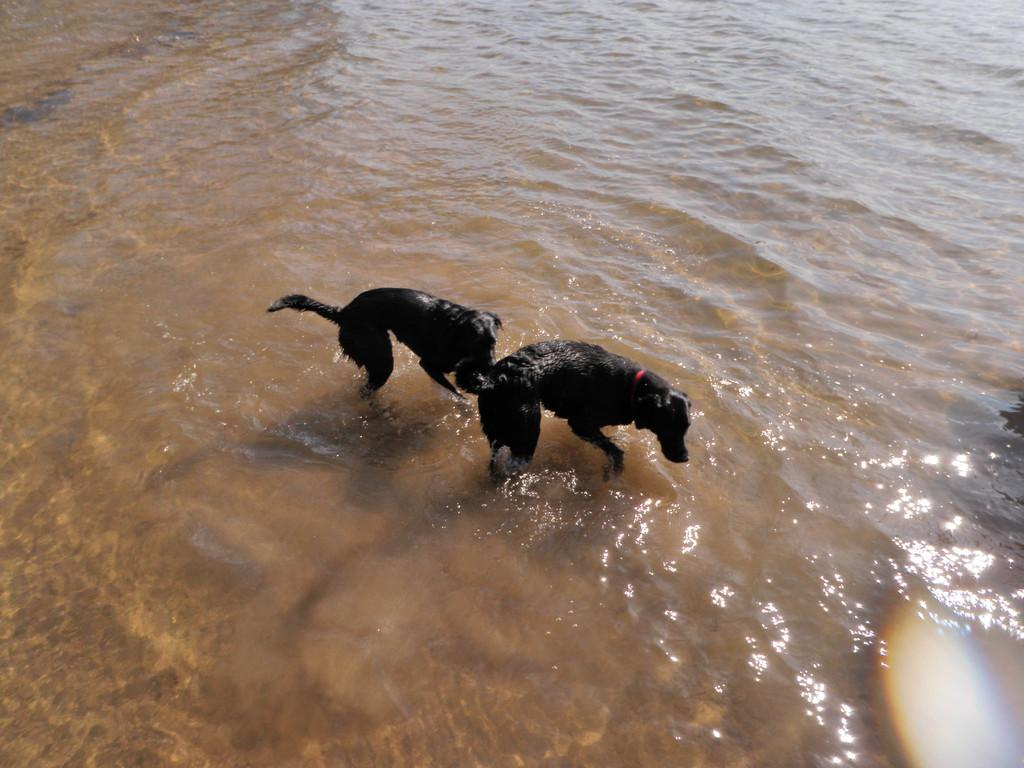How many dogs are present in the image? There are two dogs in the image. What are the dogs doing in the image? The dogs are standing in water. What type of cushion can be seen supporting the dogs in the image? There is no cushion present in the image; the dogs are standing in water. How do the dogs communicate with each other in the image? The image does not provide information about the dogs' communication, so it cannot be determined from the picture. 